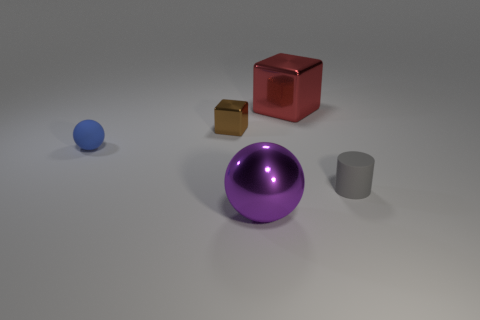What number of brown blocks are to the right of the thing in front of the tiny gray rubber thing?
Offer a very short reply. 0. Is the large thing in front of the small gray matte object made of the same material as the small blue object behind the tiny matte cylinder?
Ensure brevity in your answer.  No. What number of tiny blue objects are the same shape as the purple shiny object?
Ensure brevity in your answer.  1. Is the material of the gray cylinder the same as the small blue ball that is in front of the small brown object?
Provide a succinct answer. Yes. There is a purple sphere that is the same size as the red object; what is it made of?
Keep it short and to the point. Metal. Are there any shiny balls that have the same size as the red cube?
Keep it short and to the point. Yes. What is the shape of the purple thing that is the same size as the red metallic thing?
Your answer should be very brief. Sphere. How many other things are there of the same color as the large metallic cube?
Make the answer very short. 0. There is a metal object that is behind the small gray rubber cylinder and in front of the large red shiny cube; what is its shape?
Offer a very short reply. Cube. Are there any blocks that are on the right side of the metallic object left of the large object in front of the gray rubber cylinder?
Offer a very short reply. Yes. 